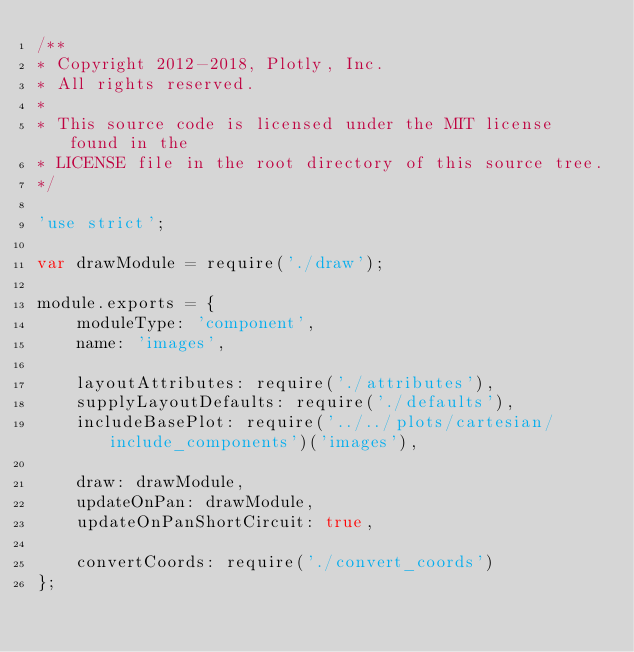Convert code to text. <code><loc_0><loc_0><loc_500><loc_500><_JavaScript_>/**
* Copyright 2012-2018, Plotly, Inc.
* All rights reserved.
*
* This source code is licensed under the MIT license found in the
* LICENSE file in the root directory of this source tree.
*/

'use strict';

var drawModule = require('./draw');

module.exports = {
    moduleType: 'component',
    name: 'images',

    layoutAttributes: require('./attributes'),
    supplyLayoutDefaults: require('./defaults'),
    includeBasePlot: require('../../plots/cartesian/include_components')('images'),

    draw: drawModule,
    updateOnPan: drawModule,
    updateOnPanShortCircuit: true,

    convertCoords: require('./convert_coords')
};
</code> 